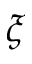<formula> <loc_0><loc_0><loc_500><loc_500>\xi</formula> 